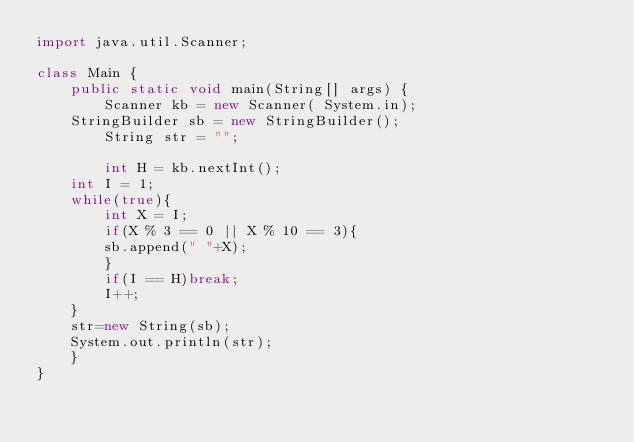Convert code to text. <code><loc_0><loc_0><loc_500><loc_500><_Java_>import java.util.Scanner;
 
class Main {
    public static void main(String[] args) {
        Scanner kb = new Scanner( System.in);   
	StringBuilder sb = new StringBuilder();
        String str = "";

        int H = kb.nextInt();
	int I = 1;
	while(true){
	    int X = I;
	    if(X % 3 == 0 || X % 10 == 3){
		sb.append(" "+X);
	    }
	    if(I == H)break;
	    I++;
	}
	str=new String(sb);
	System.out.println(str);
    }
}</code> 